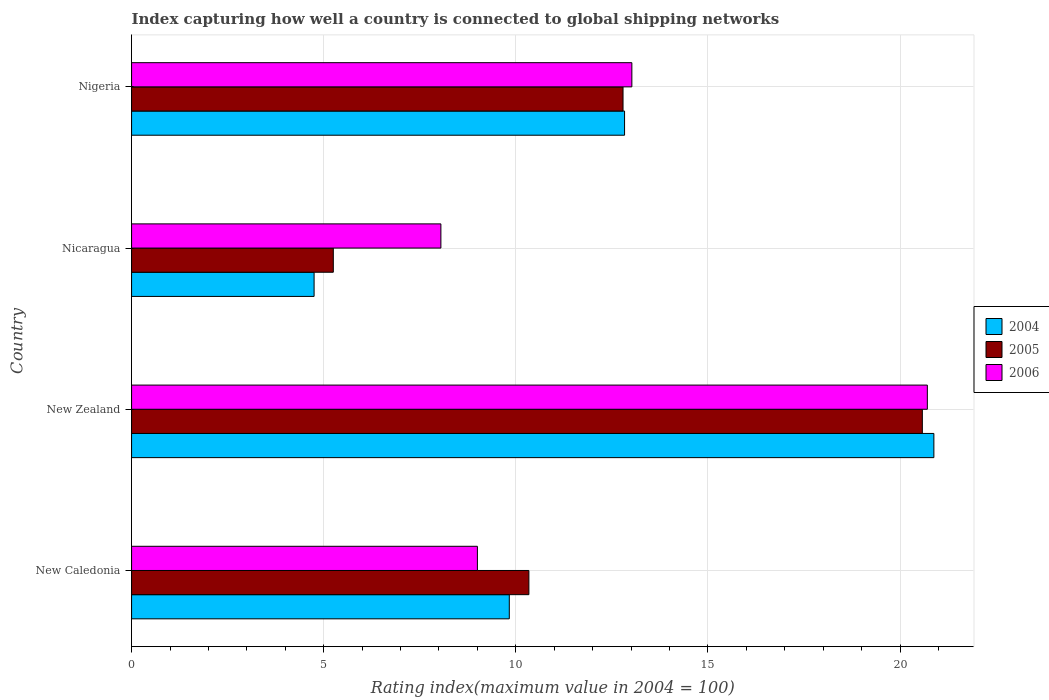How many groups of bars are there?
Your answer should be compact. 4. What is the label of the 1st group of bars from the top?
Offer a very short reply. Nigeria. What is the rating index in 2004 in Nicaragua?
Ensure brevity in your answer.  4.75. Across all countries, what is the maximum rating index in 2004?
Offer a very short reply. 20.88. Across all countries, what is the minimum rating index in 2004?
Provide a short and direct response. 4.75. In which country was the rating index in 2006 maximum?
Provide a short and direct response. New Zealand. In which country was the rating index in 2006 minimum?
Keep it short and to the point. Nicaragua. What is the total rating index in 2006 in the graph?
Make the answer very short. 50.78. What is the difference between the rating index in 2005 in New Zealand and that in Nicaragua?
Provide a succinct answer. 15.33. What is the difference between the rating index in 2004 in New Zealand and the rating index in 2006 in Nigeria?
Ensure brevity in your answer.  7.86. What is the average rating index in 2004 per country?
Your answer should be very brief. 12.07. What is the difference between the rating index in 2004 and rating index in 2006 in Nigeria?
Offer a very short reply. -0.19. In how many countries, is the rating index in 2004 greater than 7 ?
Offer a very short reply. 3. What is the ratio of the rating index in 2005 in New Zealand to that in Nigeria?
Keep it short and to the point. 1.61. What is the difference between the highest and the second highest rating index in 2005?
Make the answer very short. 7.79. What is the difference between the highest and the lowest rating index in 2005?
Provide a succinct answer. 15.33. Is the sum of the rating index in 2005 in New Zealand and Nigeria greater than the maximum rating index in 2006 across all countries?
Ensure brevity in your answer.  Yes. What does the 1st bar from the top in New Caledonia represents?
Keep it short and to the point. 2006. What does the 1st bar from the bottom in Nicaragua represents?
Ensure brevity in your answer.  2004. Is it the case that in every country, the sum of the rating index in 2005 and rating index in 2004 is greater than the rating index in 2006?
Your response must be concise. Yes. How many bars are there?
Your response must be concise. 12. Are all the bars in the graph horizontal?
Offer a very short reply. Yes. What is the difference between two consecutive major ticks on the X-axis?
Offer a very short reply. 5. Are the values on the major ticks of X-axis written in scientific E-notation?
Your response must be concise. No. Does the graph contain any zero values?
Give a very brief answer. No. How many legend labels are there?
Make the answer very short. 3. What is the title of the graph?
Offer a very short reply. Index capturing how well a country is connected to global shipping networks. What is the label or title of the X-axis?
Offer a terse response. Rating index(maximum value in 2004 = 100). What is the Rating index(maximum value in 2004 = 100) of 2004 in New Caledonia?
Give a very brief answer. 9.83. What is the Rating index(maximum value in 2004 = 100) in 2005 in New Caledonia?
Provide a succinct answer. 10.34. What is the Rating index(maximum value in 2004 = 100) of 2004 in New Zealand?
Give a very brief answer. 20.88. What is the Rating index(maximum value in 2004 = 100) of 2005 in New Zealand?
Offer a very short reply. 20.58. What is the Rating index(maximum value in 2004 = 100) in 2006 in New Zealand?
Your response must be concise. 20.71. What is the Rating index(maximum value in 2004 = 100) in 2004 in Nicaragua?
Your answer should be very brief. 4.75. What is the Rating index(maximum value in 2004 = 100) in 2005 in Nicaragua?
Ensure brevity in your answer.  5.25. What is the Rating index(maximum value in 2004 = 100) in 2006 in Nicaragua?
Offer a terse response. 8.05. What is the Rating index(maximum value in 2004 = 100) in 2004 in Nigeria?
Keep it short and to the point. 12.83. What is the Rating index(maximum value in 2004 = 100) in 2005 in Nigeria?
Your answer should be very brief. 12.79. What is the Rating index(maximum value in 2004 = 100) of 2006 in Nigeria?
Your response must be concise. 13.02. Across all countries, what is the maximum Rating index(maximum value in 2004 = 100) of 2004?
Provide a succinct answer. 20.88. Across all countries, what is the maximum Rating index(maximum value in 2004 = 100) of 2005?
Provide a succinct answer. 20.58. Across all countries, what is the maximum Rating index(maximum value in 2004 = 100) in 2006?
Provide a succinct answer. 20.71. Across all countries, what is the minimum Rating index(maximum value in 2004 = 100) of 2004?
Make the answer very short. 4.75. Across all countries, what is the minimum Rating index(maximum value in 2004 = 100) of 2005?
Offer a very short reply. 5.25. Across all countries, what is the minimum Rating index(maximum value in 2004 = 100) of 2006?
Offer a very short reply. 8.05. What is the total Rating index(maximum value in 2004 = 100) of 2004 in the graph?
Your answer should be very brief. 48.29. What is the total Rating index(maximum value in 2004 = 100) in 2005 in the graph?
Your answer should be very brief. 48.96. What is the total Rating index(maximum value in 2004 = 100) of 2006 in the graph?
Your answer should be compact. 50.78. What is the difference between the Rating index(maximum value in 2004 = 100) in 2004 in New Caledonia and that in New Zealand?
Provide a short and direct response. -11.05. What is the difference between the Rating index(maximum value in 2004 = 100) in 2005 in New Caledonia and that in New Zealand?
Make the answer very short. -10.24. What is the difference between the Rating index(maximum value in 2004 = 100) in 2006 in New Caledonia and that in New Zealand?
Offer a terse response. -11.71. What is the difference between the Rating index(maximum value in 2004 = 100) of 2004 in New Caledonia and that in Nicaragua?
Provide a succinct answer. 5.08. What is the difference between the Rating index(maximum value in 2004 = 100) of 2005 in New Caledonia and that in Nicaragua?
Keep it short and to the point. 5.09. What is the difference between the Rating index(maximum value in 2004 = 100) of 2006 in New Caledonia and that in Nicaragua?
Your answer should be very brief. 0.95. What is the difference between the Rating index(maximum value in 2004 = 100) of 2005 in New Caledonia and that in Nigeria?
Offer a very short reply. -2.45. What is the difference between the Rating index(maximum value in 2004 = 100) in 2006 in New Caledonia and that in Nigeria?
Your response must be concise. -4.02. What is the difference between the Rating index(maximum value in 2004 = 100) of 2004 in New Zealand and that in Nicaragua?
Provide a succinct answer. 16.13. What is the difference between the Rating index(maximum value in 2004 = 100) of 2005 in New Zealand and that in Nicaragua?
Your answer should be very brief. 15.33. What is the difference between the Rating index(maximum value in 2004 = 100) of 2006 in New Zealand and that in Nicaragua?
Give a very brief answer. 12.66. What is the difference between the Rating index(maximum value in 2004 = 100) of 2004 in New Zealand and that in Nigeria?
Make the answer very short. 8.05. What is the difference between the Rating index(maximum value in 2004 = 100) in 2005 in New Zealand and that in Nigeria?
Your answer should be very brief. 7.79. What is the difference between the Rating index(maximum value in 2004 = 100) of 2006 in New Zealand and that in Nigeria?
Keep it short and to the point. 7.69. What is the difference between the Rating index(maximum value in 2004 = 100) in 2004 in Nicaragua and that in Nigeria?
Your answer should be very brief. -8.08. What is the difference between the Rating index(maximum value in 2004 = 100) in 2005 in Nicaragua and that in Nigeria?
Make the answer very short. -7.54. What is the difference between the Rating index(maximum value in 2004 = 100) of 2006 in Nicaragua and that in Nigeria?
Make the answer very short. -4.97. What is the difference between the Rating index(maximum value in 2004 = 100) in 2004 in New Caledonia and the Rating index(maximum value in 2004 = 100) in 2005 in New Zealand?
Your response must be concise. -10.75. What is the difference between the Rating index(maximum value in 2004 = 100) of 2004 in New Caledonia and the Rating index(maximum value in 2004 = 100) of 2006 in New Zealand?
Provide a short and direct response. -10.88. What is the difference between the Rating index(maximum value in 2004 = 100) in 2005 in New Caledonia and the Rating index(maximum value in 2004 = 100) in 2006 in New Zealand?
Your response must be concise. -10.37. What is the difference between the Rating index(maximum value in 2004 = 100) in 2004 in New Caledonia and the Rating index(maximum value in 2004 = 100) in 2005 in Nicaragua?
Provide a short and direct response. 4.58. What is the difference between the Rating index(maximum value in 2004 = 100) in 2004 in New Caledonia and the Rating index(maximum value in 2004 = 100) in 2006 in Nicaragua?
Make the answer very short. 1.78. What is the difference between the Rating index(maximum value in 2004 = 100) of 2005 in New Caledonia and the Rating index(maximum value in 2004 = 100) of 2006 in Nicaragua?
Provide a short and direct response. 2.29. What is the difference between the Rating index(maximum value in 2004 = 100) of 2004 in New Caledonia and the Rating index(maximum value in 2004 = 100) of 2005 in Nigeria?
Keep it short and to the point. -2.96. What is the difference between the Rating index(maximum value in 2004 = 100) in 2004 in New Caledonia and the Rating index(maximum value in 2004 = 100) in 2006 in Nigeria?
Offer a terse response. -3.19. What is the difference between the Rating index(maximum value in 2004 = 100) in 2005 in New Caledonia and the Rating index(maximum value in 2004 = 100) in 2006 in Nigeria?
Give a very brief answer. -2.68. What is the difference between the Rating index(maximum value in 2004 = 100) of 2004 in New Zealand and the Rating index(maximum value in 2004 = 100) of 2005 in Nicaragua?
Offer a very short reply. 15.63. What is the difference between the Rating index(maximum value in 2004 = 100) of 2004 in New Zealand and the Rating index(maximum value in 2004 = 100) of 2006 in Nicaragua?
Give a very brief answer. 12.83. What is the difference between the Rating index(maximum value in 2004 = 100) in 2005 in New Zealand and the Rating index(maximum value in 2004 = 100) in 2006 in Nicaragua?
Your response must be concise. 12.53. What is the difference between the Rating index(maximum value in 2004 = 100) of 2004 in New Zealand and the Rating index(maximum value in 2004 = 100) of 2005 in Nigeria?
Provide a succinct answer. 8.09. What is the difference between the Rating index(maximum value in 2004 = 100) in 2004 in New Zealand and the Rating index(maximum value in 2004 = 100) in 2006 in Nigeria?
Your answer should be very brief. 7.86. What is the difference between the Rating index(maximum value in 2004 = 100) of 2005 in New Zealand and the Rating index(maximum value in 2004 = 100) of 2006 in Nigeria?
Your answer should be very brief. 7.56. What is the difference between the Rating index(maximum value in 2004 = 100) in 2004 in Nicaragua and the Rating index(maximum value in 2004 = 100) in 2005 in Nigeria?
Your response must be concise. -8.04. What is the difference between the Rating index(maximum value in 2004 = 100) in 2004 in Nicaragua and the Rating index(maximum value in 2004 = 100) in 2006 in Nigeria?
Provide a short and direct response. -8.27. What is the difference between the Rating index(maximum value in 2004 = 100) in 2005 in Nicaragua and the Rating index(maximum value in 2004 = 100) in 2006 in Nigeria?
Ensure brevity in your answer.  -7.77. What is the average Rating index(maximum value in 2004 = 100) of 2004 per country?
Offer a terse response. 12.07. What is the average Rating index(maximum value in 2004 = 100) in 2005 per country?
Provide a short and direct response. 12.24. What is the average Rating index(maximum value in 2004 = 100) of 2006 per country?
Offer a very short reply. 12.7. What is the difference between the Rating index(maximum value in 2004 = 100) of 2004 and Rating index(maximum value in 2004 = 100) of 2005 in New Caledonia?
Your answer should be very brief. -0.51. What is the difference between the Rating index(maximum value in 2004 = 100) in 2004 and Rating index(maximum value in 2004 = 100) in 2006 in New Caledonia?
Your response must be concise. 0.83. What is the difference between the Rating index(maximum value in 2004 = 100) in 2005 and Rating index(maximum value in 2004 = 100) in 2006 in New Caledonia?
Your answer should be compact. 1.34. What is the difference between the Rating index(maximum value in 2004 = 100) in 2004 and Rating index(maximum value in 2004 = 100) in 2005 in New Zealand?
Your answer should be very brief. 0.3. What is the difference between the Rating index(maximum value in 2004 = 100) in 2004 and Rating index(maximum value in 2004 = 100) in 2006 in New Zealand?
Your answer should be compact. 0.17. What is the difference between the Rating index(maximum value in 2004 = 100) in 2005 and Rating index(maximum value in 2004 = 100) in 2006 in New Zealand?
Provide a short and direct response. -0.13. What is the difference between the Rating index(maximum value in 2004 = 100) of 2004 and Rating index(maximum value in 2004 = 100) of 2005 in Nicaragua?
Provide a succinct answer. -0.5. What is the difference between the Rating index(maximum value in 2004 = 100) of 2005 and Rating index(maximum value in 2004 = 100) of 2006 in Nicaragua?
Your answer should be very brief. -2.8. What is the difference between the Rating index(maximum value in 2004 = 100) of 2004 and Rating index(maximum value in 2004 = 100) of 2006 in Nigeria?
Make the answer very short. -0.19. What is the difference between the Rating index(maximum value in 2004 = 100) of 2005 and Rating index(maximum value in 2004 = 100) of 2006 in Nigeria?
Keep it short and to the point. -0.23. What is the ratio of the Rating index(maximum value in 2004 = 100) in 2004 in New Caledonia to that in New Zealand?
Your response must be concise. 0.47. What is the ratio of the Rating index(maximum value in 2004 = 100) in 2005 in New Caledonia to that in New Zealand?
Provide a short and direct response. 0.5. What is the ratio of the Rating index(maximum value in 2004 = 100) in 2006 in New Caledonia to that in New Zealand?
Your answer should be compact. 0.43. What is the ratio of the Rating index(maximum value in 2004 = 100) in 2004 in New Caledonia to that in Nicaragua?
Provide a short and direct response. 2.07. What is the ratio of the Rating index(maximum value in 2004 = 100) in 2005 in New Caledonia to that in Nicaragua?
Keep it short and to the point. 1.97. What is the ratio of the Rating index(maximum value in 2004 = 100) of 2006 in New Caledonia to that in Nicaragua?
Provide a short and direct response. 1.12. What is the ratio of the Rating index(maximum value in 2004 = 100) in 2004 in New Caledonia to that in Nigeria?
Ensure brevity in your answer.  0.77. What is the ratio of the Rating index(maximum value in 2004 = 100) in 2005 in New Caledonia to that in Nigeria?
Provide a succinct answer. 0.81. What is the ratio of the Rating index(maximum value in 2004 = 100) in 2006 in New Caledonia to that in Nigeria?
Keep it short and to the point. 0.69. What is the ratio of the Rating index(maximum value in 2004 = 100) of 2004 in New Zealand to that in Nicaragua?
Provide a short and direct response. 4.4. What is the ratio of the Rating index(maximum value in 2004 = 100) in 2005 in New Zealand to that in Nicaragua?
Your answer should be compact. 3.92. What is the ratio of the Rating index(maximum value in 2004 = 100) in 2006 in New Zealand to that in Nicaragua?
Offer a very short reply. 2.57. What is the ratio of the Rating index(maximum value in 2004 = 100) in 2004 in New Zealand to that in Nigeria?
Your answer should be compact. 1.63. What is the ratio of the Rating index(maximum value in 2004 = 100) of 2005 in New Zealand to that in Nigeria?
Ensure brevity in your answer.  1.61. What is the ratio of the Rating index(maximum value in 2004 = 100) in 2006 in New Zealand to that in Nigeria?
Your answer should be compact. 1.59. What is the ratio of the Rating index(maximum value in 2004 = 100) of 2004 in Nicaragua to that in Nigeria?
Your answer should be very brief. 0.37. What is the ratio of the Rating index(maximum value in 2004 = 100) of 2005 in Nicaragua to that in Nigeria?
Provide a short and direct response. 0.41. What is the ratio of the Rating index(maximum value in 2004 = 100) of 2006 in Nicaragua to that in Nigeria?
Your answer should be very brief. 0.62. What is the difference between the highest and the second highest Rating index(maximum value in 2004 = 100) in 2004?
Your answer should be compact. 8.05. What is the difference between the highest and the second highest Rating index(maximum value in 2004 = 100) in 2005?
Ensure brevity in your answer.  7.79. What is the difference between the highest and the second highest Rating index(maximum value in 2004 = 100) of 2006?
Make the answer very short. 7.69. What is the difference between the highest and the lowest Rating index(maximum value in 2004 = 100) of 2004?
Make the answer very short. 16.13. What is the difference between the highest and the lowest Rating index(maximum value in 2004 = 100) of 2005?
Give a very brief answer. 15.33. What is the difference between the highest and the lowest Rating index(maximum value in 2004 = 100) of 2006?
Offer a very short reply. 12.66. 